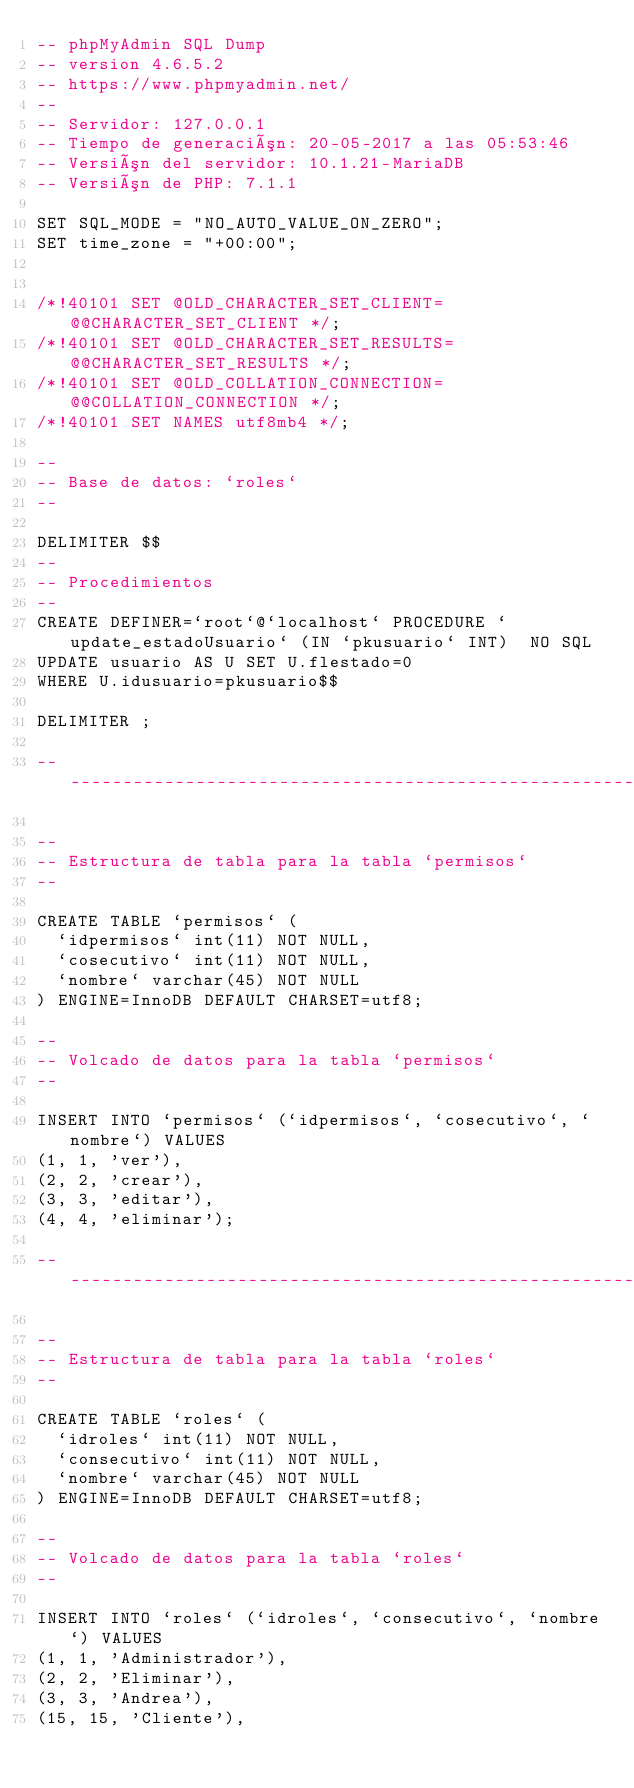Convert code to text. <code><loc_0><loc_0><loc_500><loc_500><_SQL_>-- phpMyAdmin SQL Dump
-- version 4.6.5.2
-- https://www.phpmyadmin.net/
--
-- Servidor: 127.0.0.1
-- Tiempo de generación: 20-05-2017 a las 05:53:46
-- Versión del servidor: 10.1.21-MariaDB
-- Versión de PHP: 7.1.1

SET SQL_MODE = "NO_AUTO_VALUE_ON_ZERO";
SET time_zone = "+00:00";


/*!40101 SET @OLD_CHARACTER_SET_CLIENT=@@CHARACTER_SET_CLIENT */;
/*!40101 SET @OLD_CHARACTER_SET_RESULTS=@@CHARACTER_SET_RESULTS */;
/*!40101 SET @OLD_COLLATION_CONNECTION=@@COLLATION_CONNECTION */;
/*!40101 SET NAMES utf8mb4 */;

--
-- Base de datos: `roles`
--

DELIMITER $$
--
-- Procedimientos
--
CREATE DEFINER=`root`@`localhost` PROCEDURE `update_estadoUsuario` (IN `pkusuario` INT)  NO SQL
UPDATE usuario AS U SET U.flestado=0
WHERE U.idusuario=pkusuario$$

DELIMITER ;

-- --------------------------------------------------------

--
-- Estructura de tabla para la tabla `permisos`
--

CREATE TABLE `permisos` (
  `idpermisos` int(11) NOT NULL,
  `cosecutivo` int(11) NOT NULL,
  `nombre` varchar(45) NOT NULL
) ENGINE=InnoDB DEFAULT CHARSET=utf8;

--
-- Volcado de datos para la tabla `permisos`
--

INSERT INTO `permisos` (`idpermisos`, `cosecutivo`, `nombre`) VALUES
(1, 1, 'ver'),
(2, 2, 'crear'),
(3, 3, 'editar'),
(4, 4, 'eliminar');

-- --------------------------------------------------------

--
-- Estructura de tabla para la tabla `roles`
--

CREATE TABLE `roles` (
  `idroles` int(11) NOT NULL,
  `consecutivo` int(11) NOT NULL,
  `nombre` varchar(45) NOT NULL
) ENGINE=InnoDB DEFAULT CHARSET=utf8;

--
-- Volcado de datos para la tabla `roles`
--

INSERT INTO `roles` (`idroles`, `consecutivo`, `nombre`) VALUES
(1, 1, 'Administrador'),
(2, 2, 'Eliminar'),
(3, 3, 'Andrea'),
(15, 15, 'Cliente'),</code> 